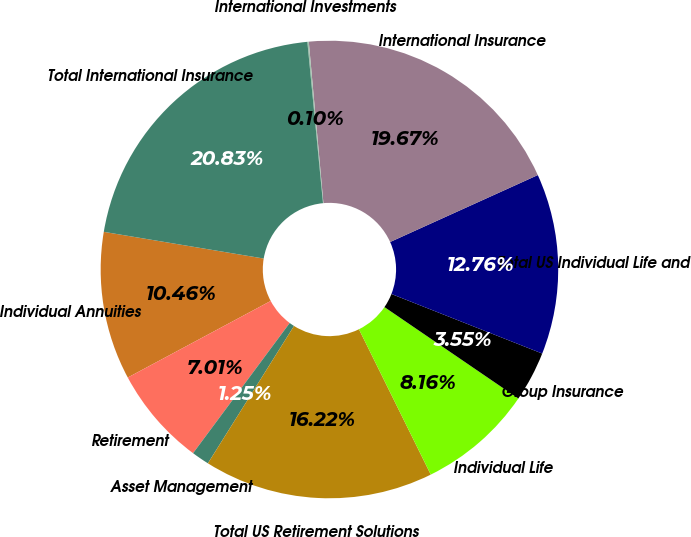Convert chart to OTSL. <chart><loc_0><loc_0><loc_500><loc_500><pie_chart><fcel>Individual Annuities<fcel>Retirement<fcel>Asset Management<fcel>Total US Retirement Solutions<fcel>Individual Life<fcel>Group Insurance<fcel>Total US Individual Life and<fcel>International Insurance<fcel>International Investments<fcel>Total International Insurance<nl><fcel>10.46%<fcel>7.01%<fcel>1.25%<fcel>16.22%<fcel>8.16%<fcel>3.55%<fcel>12.76%<fcel>19.67%<fcel>0.1%<fcel>20.83%<nl></chart> 